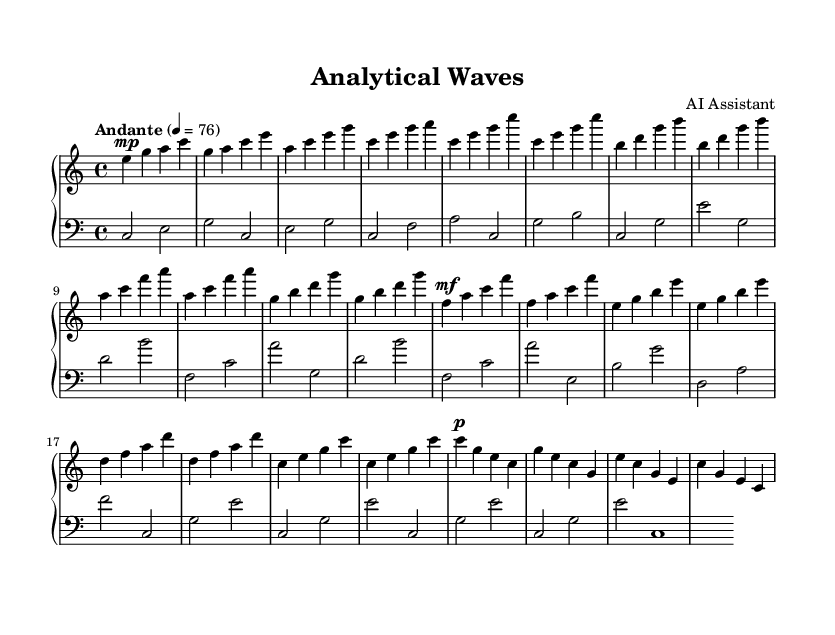What is the key signature of this music? The key signature is C major, which is indicated by no sharps or flats in the music. This can be identified by the positioning of notes on the staff and the absence of accidentals (sharps or flats) alongside the notes.
Answer: C major What is the time signature of this piece? The time signature is 4/4, which denotes that there are four beats in each measure and the quarter note gets one beat. This can be determined from the notation typically placed at the beginning of the music.
Answer: 4/4 What is the indicated tempo for this composition? The tempo is marked as "Andante," which suggests a moderately slow pace. The text indicating tempo can often be found at the beginning of the piece.
Answer: Andante How many sections are present in the composition? There are three distinct sections: Introduction, Section A, Section B, and a Coda. Counting these sections involves identifying the different headings or labels that separate the parts within the music.
Answer: 4 What dynamic marking is found at the beginning of Section B? Section B starts with a dynamic marking of mf (mezzo-forte), indicating a moderately loud intensity. This is identified by looking for dynamic symbols written above or below the staff at the beginning of that section.
Answer: mf What instruments are specified in the score? The score specifies the use of the acoustic grand piano for both the right and left hand parts. This can be verified by looking at the instrument labeling typically found at the beginning of the staff.
Answer: Acoustic grand 